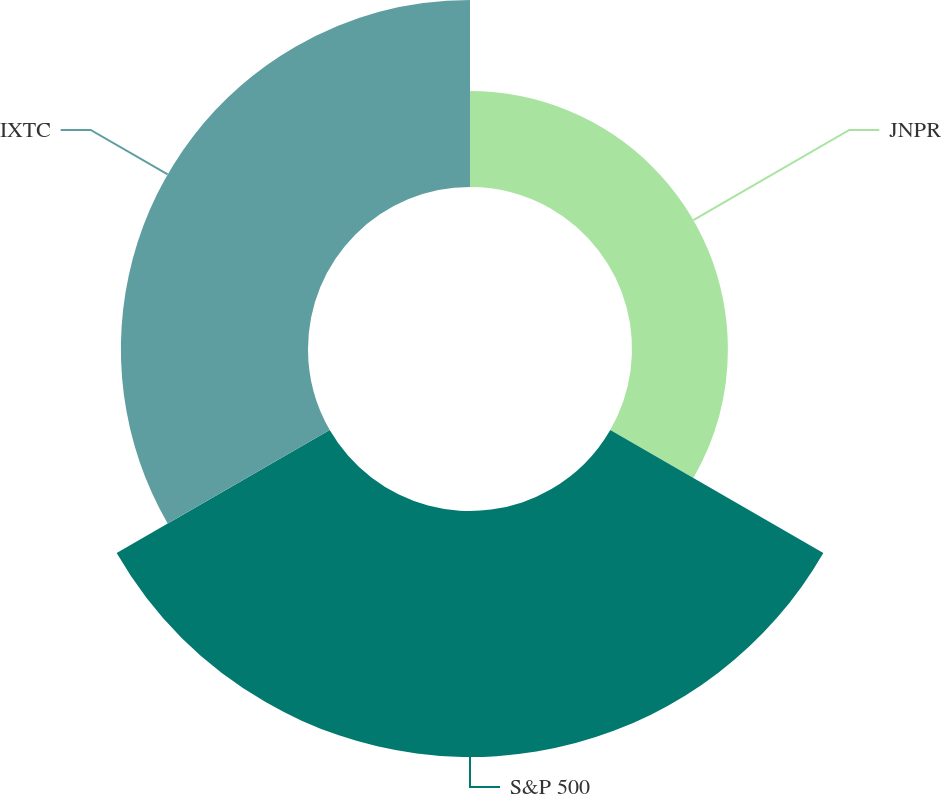<chart> <loc_0><loc_0><loc_500><loc_500><pie_chart><fcel>JNPR<fcel>S&P 500<fcel>IXTC<nl><fcel>18.13%<fcel>46.5%<fcel>35.37%<nl></chart> 